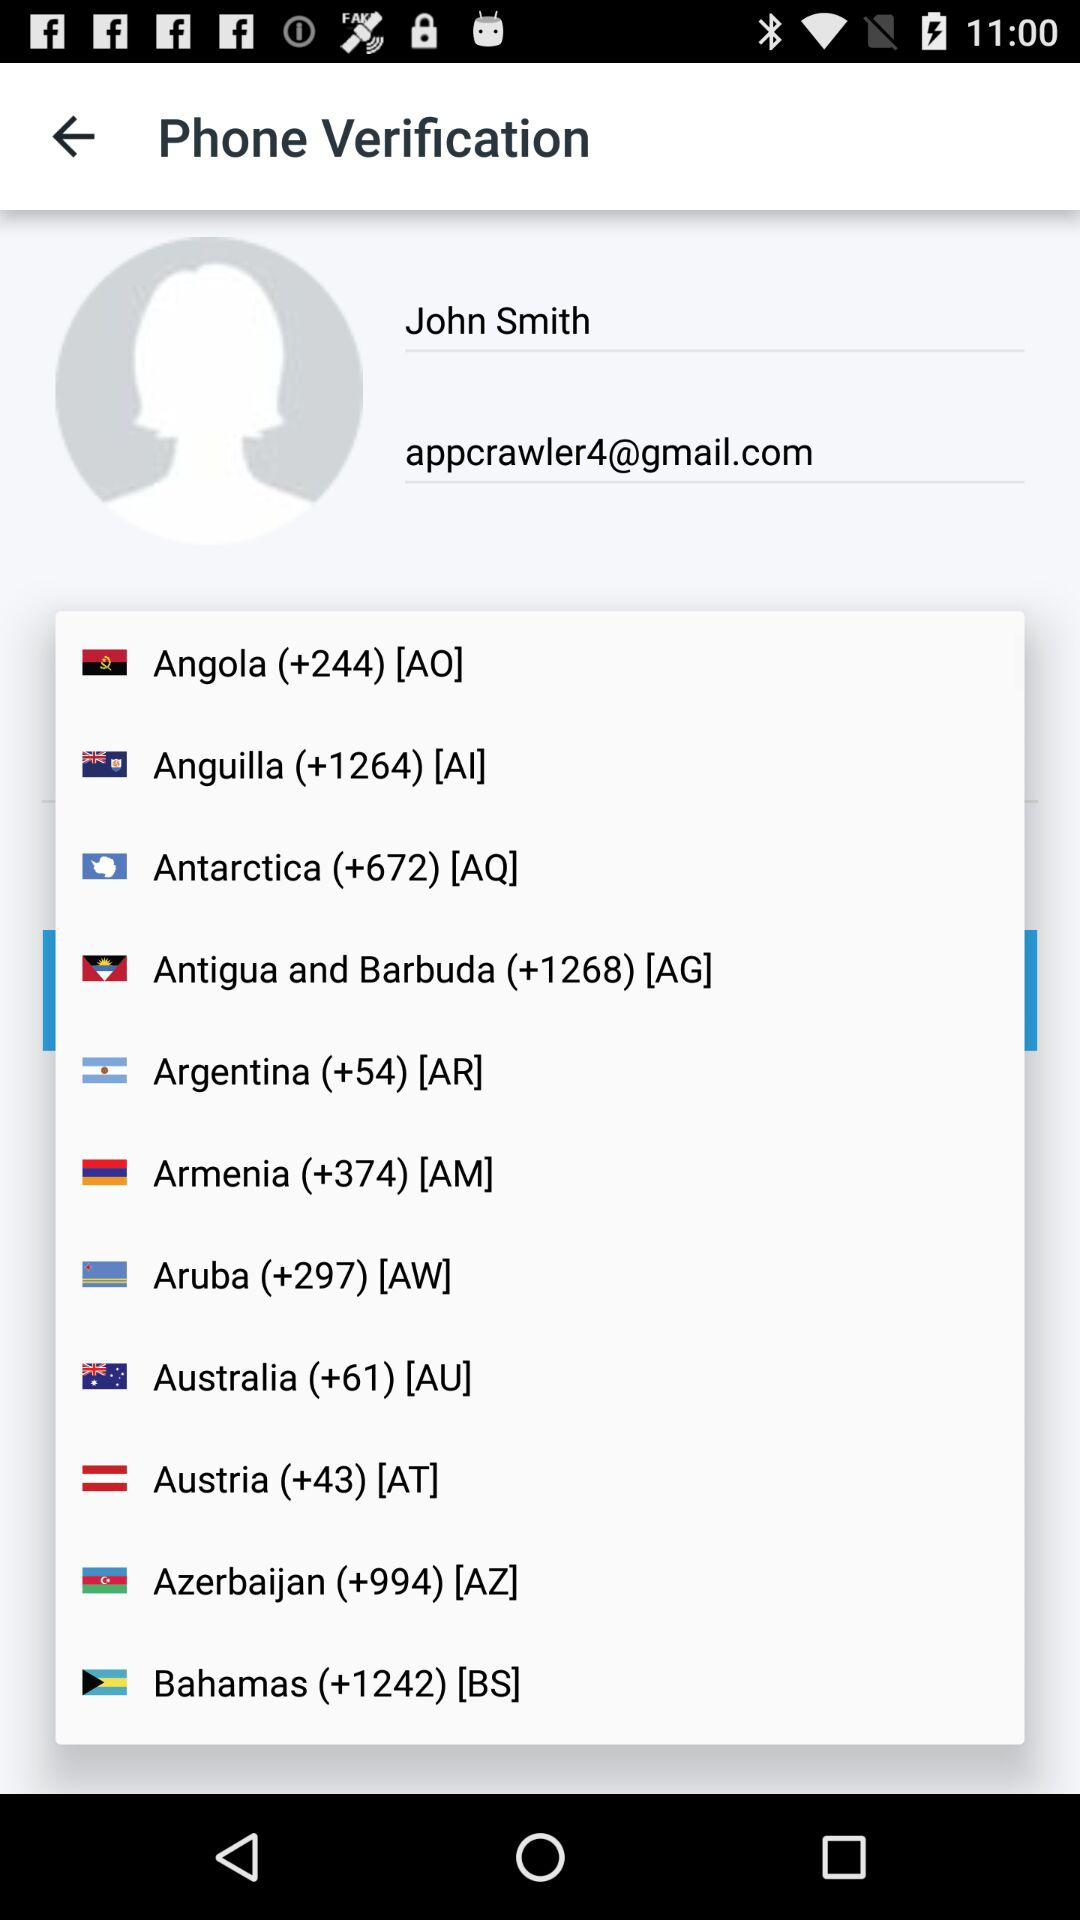What is the country code for Australia? The country code for Australia is +61. 